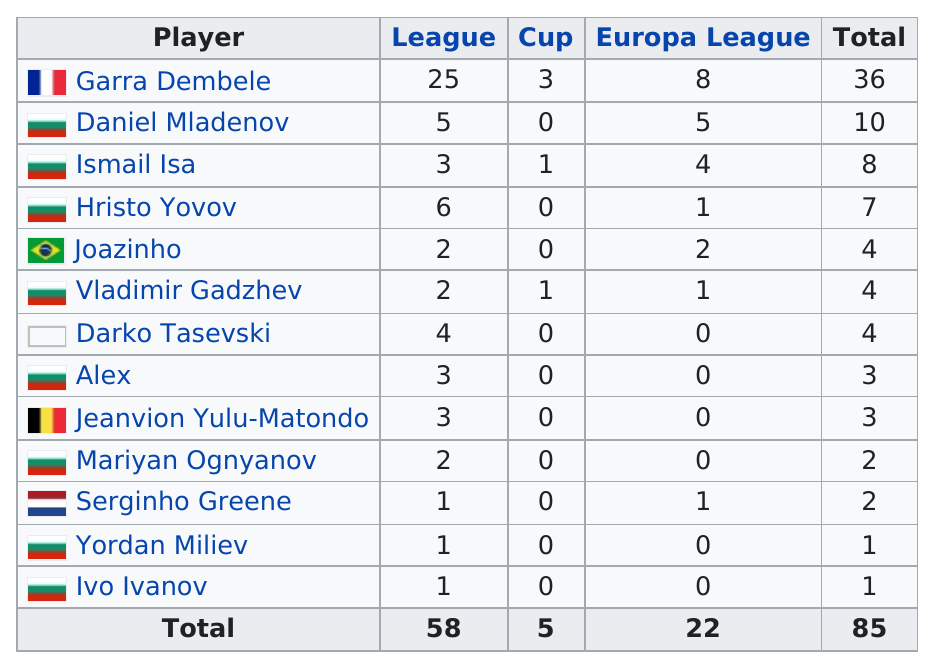Point out several critical features in this image. A total of 4 was achieved by a group of players that included 3. I have determined that the top goalscorer on this team was a player named Garra Dembele. Yordan Mihaylov's score is different from Vladimir Gadzhev's score by 3 points. Ismail Isa has scored a total of 8 goals this season, making him a top scorer. Mariyan Ognyanov is in the same league as Joazinho and Vladimir Gadzhev. 